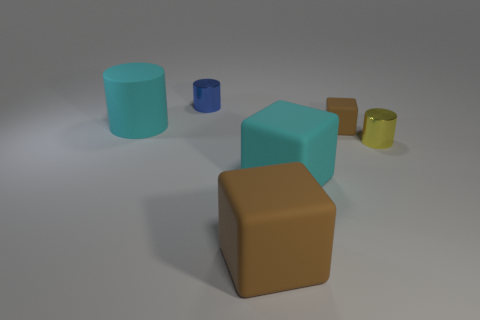Is the size of the blue metal object the same as the shiny cylinder right of the tiny brown rubber cube?
Give a very brief answer. Yes. Are there an equal number of rubber things behind the small blue metal object and tiny brown blocks that are in front of the small yellow object?
Keep it short and to the point. Yes. There is a big object that is the same color as the small matte block; what shape is it?
Your answer should be compact. Cube. There is a big cyan object that is right of the blue metal cylinder; what is it made of?
Ensure brevity in your answer.  Rubber. Is the size of the yellow object the same as the blue thing?
Your response must be concise. Yes. Is the number of cyan objects that are in front of the cyan matte cylinder greater than the number of large gray metal things?
Ensure brevity in your answer.  Yes. There is a cyan thing that is the same material as the cyan cylinder; what size is it?
Your answer should be very brief. Large. There is a tiny yellow cylinder; are there any big cyan objects in front of it?
Keep it short and to the point. Yes. Does the yellow thing have the same shape as the blue shiny thing?
Give a very brief answer. Yes. There is a cyan thing on the right side of the blue metallic cylinder that is behind the brown block in front of the yellow cylinder; what size is it?
Make the answer very short. Large. 